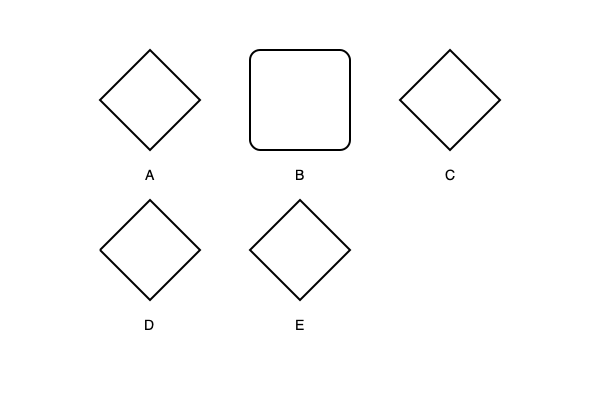Based on the tooth shapes represented in the diagram, which prehistoric animal would most likely be a herbivore? To determine which prehistoric animal would most likely be a herbivore based on tooth shape, we need to consider the functional adaptations of teeth for different diets:

1. Tooth A: Sharp, pointed shape with a triangular profile. This is typical of carnivores, designed for piercing and tearing meat.

2. Tooth B: Flat, broad surface with a rectangular shape. This is characteristic of herbivores, adapted for grinding and crushing plant material.

3. Tooth C: Combination of pointed and flat surfaces. This mix suggests an omnivorous diet, capable of processing both meat and plant matter.

4. Tooth D: Multiple pointed cusps. This shape is often associated with insectivores, adapted for crushing insect exoskeletons.

5. Tooth E: Conical shape with a sharp point. This is typical of piscivores (fish-eaters), designed for grasping slippery prey.

Among these options, Tooth B stands out as the most likely herbivore tooth. Its flat, broad surface is ideal for the grinding motion required to break down tough plant fibers. Herbivorous dinosaurs like Triceratops or Stegosaurus would have had similar tooth structures to efficiently process their plant-based diets.
Answer: B 